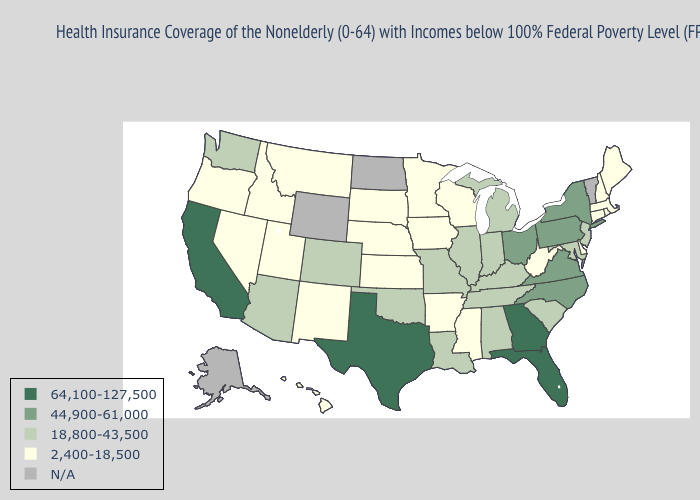Name the states that have a value in the range 64,100-127,500?
Give a very brief answer. California, Florida, Georgia, Texas. What is the value of Nebraska?
Answer briefly. 2,400-18,500. Does California have the lowest value in the West?
Write a very short answer. No. Name the states that have a value in the range 64,100-127,500?
Short answer required. California, Florida, Georgia, Texas. Which states have the lowest value in the Northeast?
Give a very brief answer. Connecticut, Maine, Massachusetts, New Hampshire, Rhode Island. What is the value of North Carolina?
Give a very brief answer. 44,900-61,000. Name the states that have a value in the range 18,800-43,500?
Answer briefly. Alabama, Arizona, Colorado, Illinois, Indiana, Kentucky, Louisiana, Maryland, Michigan, Missouri, New Jersey, Oklahoma, South Carolina, Tennessee, Washington. What is the value of Oklahoma?
Write a very short answer. 18,800-43,500. What is the value of New Mexico?
Give a very brief answer. 2,400-18,500. What is the value of New Hampshire?
Quick response, please. 2,400-18,500. Does Tennessee have the lowest value in the South?
Quick response, please. No. Name the states that have a value in the range 44,900-61,000?
Answer briefly. New York, North Carolina, Ohio, Pennsylvania, Virginia. Name the states that have a value in the range 64,100-127,500?
Short answer required. California, Florida, Georgia, Texas. 